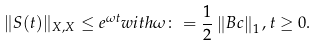<formula> <loc_0><loc_0><loc_500><loc_500>\| S ( t ) \| _ { X , X } \leq e ^ { \omega t } w i t h \omega \colon = \frac { 1 } { 2 } \left \| B c \right \| _ { 1 } , t \geq 0 .</formula> 